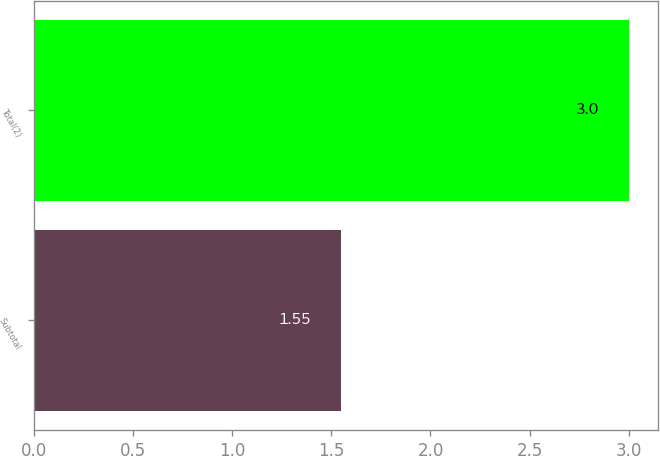Convert chart. <chart><loc_0><loc_0><loc_500><loc_500><bar_chart><fcel>Subtotal<fcel>Total(2)<nl><fcel>1.55<fcel>3<nl></chart> 